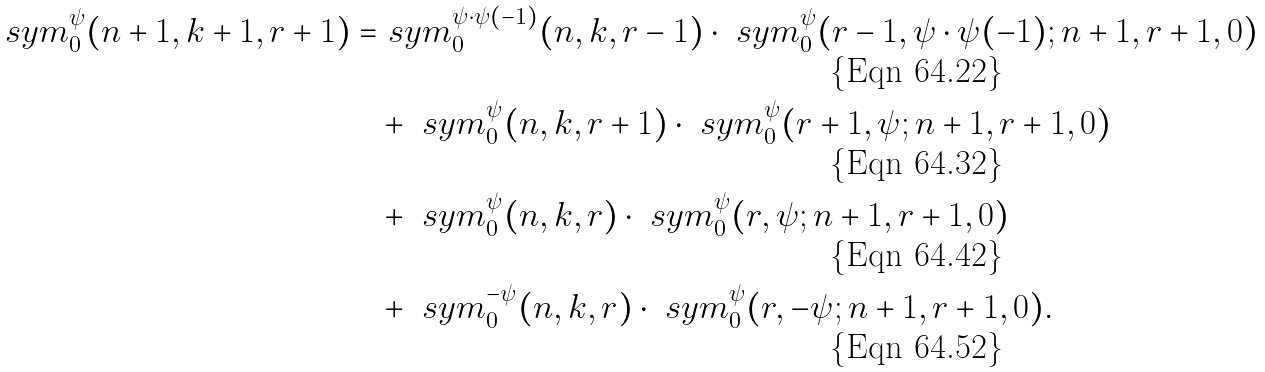<formula> <loc_0><loc_0><loc_500><loc_500>\ s y m _ { 0 } ^ { \psi } ( n + 1 , k + 1 , r + 1 ) = & \ s y m _ { 0 } ^ { \psi \cdot \psi ( - 1 ) } ( n , k , r - 1 ) \cdot \ s y m _ { 0 } ^ { \psi } ( r - 1 , \psi \cdot \psi ( - 1 ) ; n + 1 , r + 1 , 0 ) \\ & + \ s y m _ { 0 } ^ { \psi } ( n , k , r + 1 ) \cdot \ s y m _ { 0 } ^ { \psi } ( r + 1 , \psi ; n + 1 , r + 1 , 0 ) \\ & + \ s y m _ { 0 } ^ { \psi } ( n , k , r ) \cdot \ s y m _ { 0 } ^ { \psi } ( r , \psi ; n + 1 , r + 1 , 0 ) \\ & + \ s y m _ { 0 } ^ { - \psi } ( n , k , r ) \cdot \ s y m _ { 0 } ^ { \psi } ( r , - \psi ; n + 1 , r + 1 , 0 ) .</formula> 